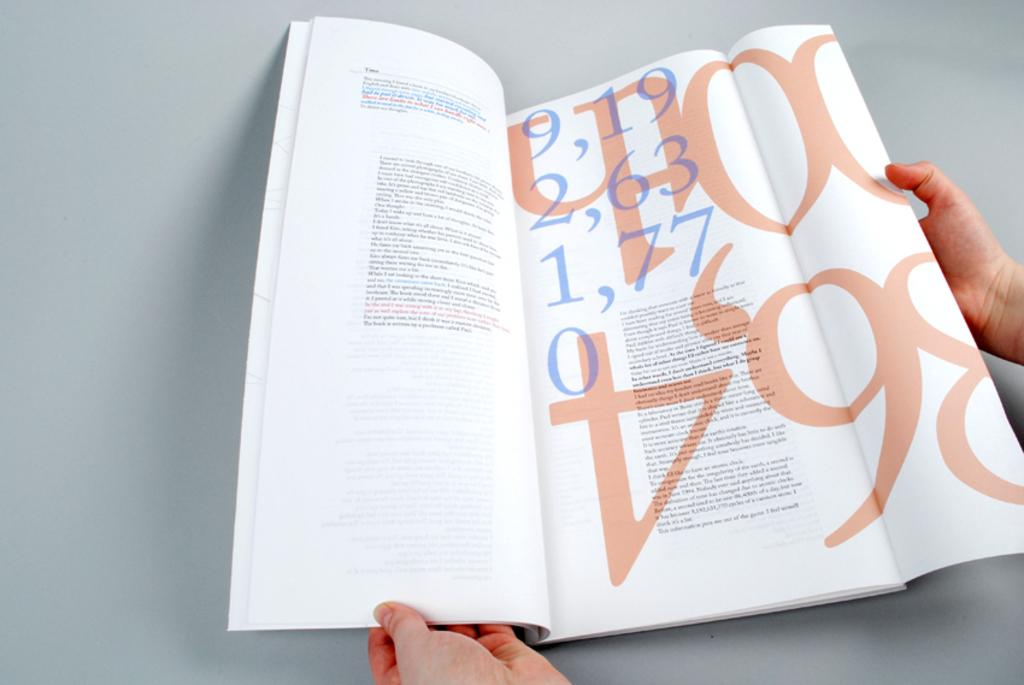Provide a one-sentence caption for the provided image. A magazine being held open to show the number 9,19 2,63 1,77 and 0. 